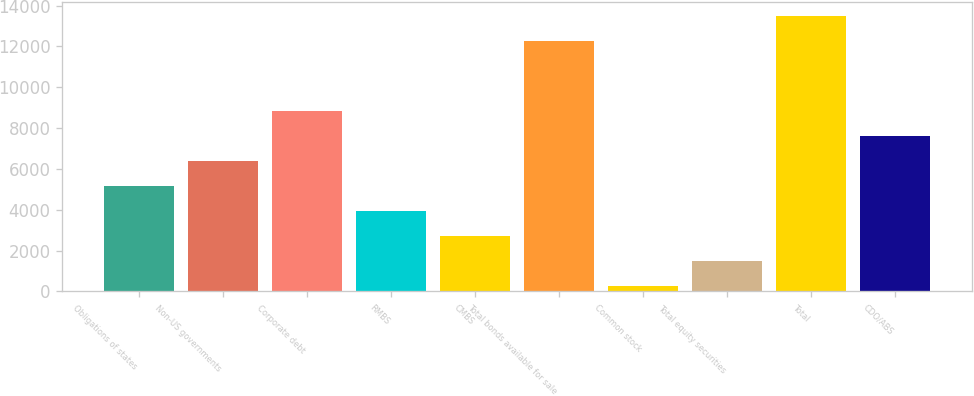Convert chart to OTSL. <chart><loc_0><loc_0><loc_500><loc_500><bar_chart><fcel>Obligations of states<fcel>Non-US governments<fcel>Corporate debt<fcel>RMBS<fcel>CMBS<fcel>Total bonds available for sale<fcel>Common stock<fcel>Total equity securities<fcel>Total<fcel>CDO/ABS<nl><fcel>5159<fcel>6387<fcel>8843<fcel>3931<fcel>2703<fcel>12277<fcel>247<fcel>1475<fcel>13505<fcel>7615<nl></chart> 